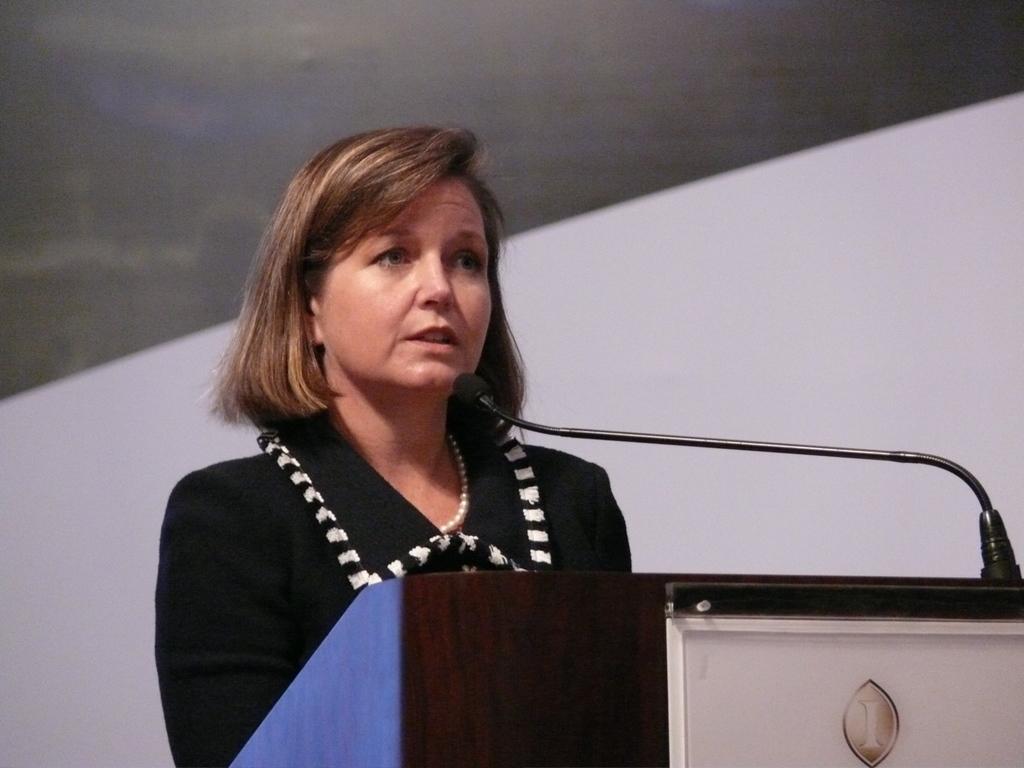In one or two sentences, can you explain what this image depicts? In the image there is a woman in black dress talking in mic in front of dias, behind her its a wall. 